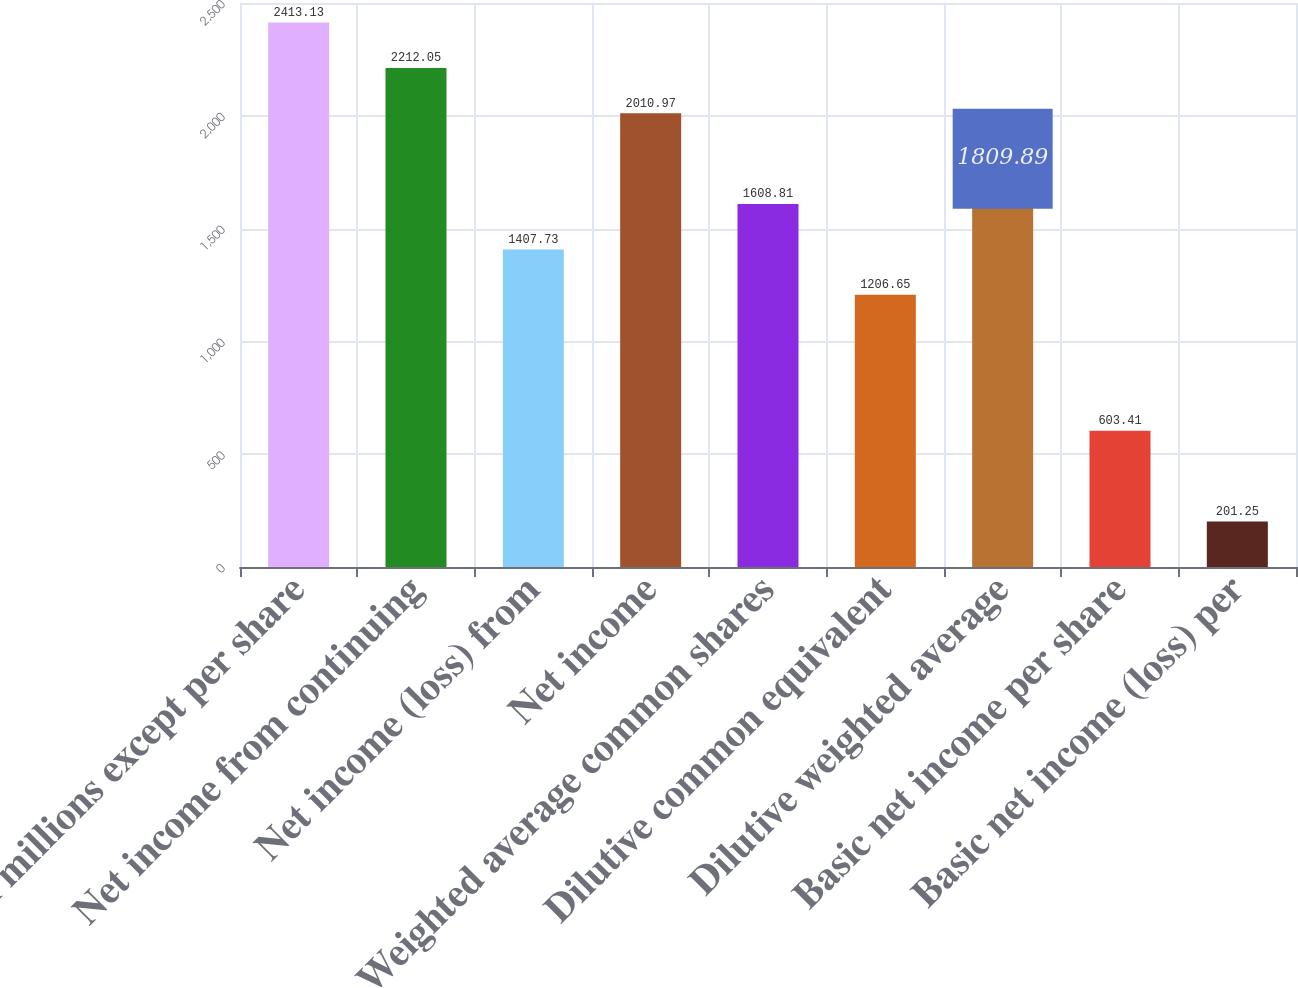Convert chart. <chart><loc_0><loc_0><loc_500><loc_500><bar_chart><fcel>(In millions except per share<fcel>Net income from continuing<fcel>Net income (loss) from<fcel>Net income<fcel>Weighted average common shares<fcel>Dilutive common equivalent<fcel>Dilutive weighted average<fcel>Basic net income per share<fcel>Basic net income (loss) per<nl><fcel>2413.13<fcel>2212.05<fcel>1407.73<fcel>2010.97<fcel>1608.81<fcel>1206.65<fcel>1809.89<fcel>603.41<fcel>201.25<nl></chart> 